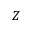Convert formula to latex. <formula><loc_0><loc_0><loc_500><loc_500>Z</formula> 